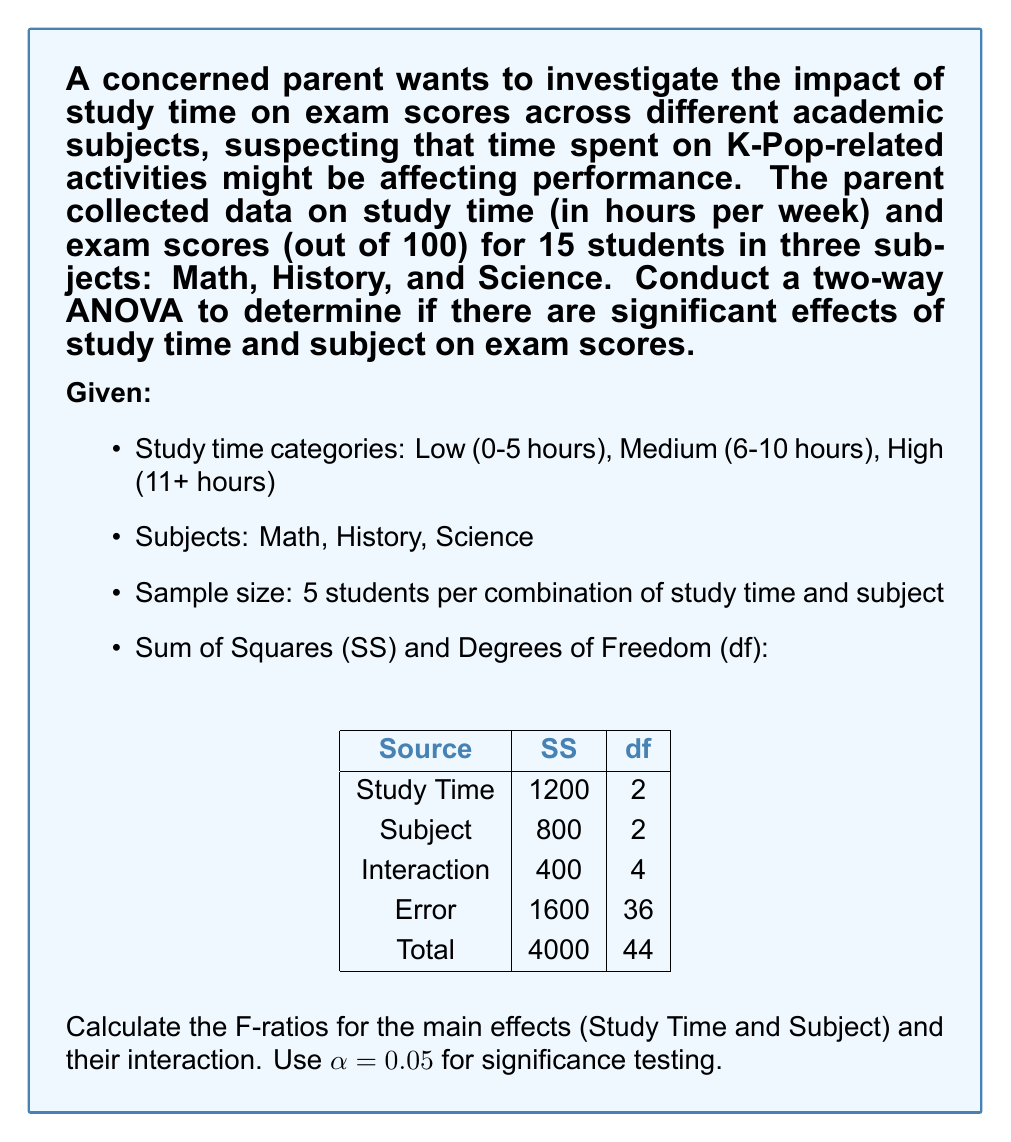Provide a solution to this math problem. To conduct a two-way ANOVA, we need to calculate the Mean Square (MS) for each source of variation and then compute the F-ratios. Here's a step-by-step explanation:

1. Calculate Mean Squares (MS):
   MS = SS / df
   
   For Study Time: $MS_{StudyTime} = 1200 / 2 = 600$
   For Subject: $MS_{Subject} = 800 / 2 = 400$
   For Interaction: $MS_{Interaction} = 400 / 4 = 100$
   For Error: $MS_{Error} = 1600 / 36 \approx 44.44$

2. Calculate F-ratios:
   F-ratio = MS(effect) / MS(error)
   
   For Study Time: $F_{StudyTime} = 600 / 44.44 \approx 13.50$
   For Subject: $F_{Subject} = 400 / 44.44 \approx 9.00$
   For Interaction: $F_{Interaction} = 100 / 44.44 \approx 2.25$

3. Determine critical F-values:
   For $\alpha = 0.05$:
   $F_{crit}(2, 36) \approx 3.26$ (for Study Time and Subject)
   $F_{crit}(4, 36) \approx 2.63$ (for Interaction)

4. Compare F-ratios to critical F-values:
   Study Time: 13.50 > 3.26, significant effect
   Subject: 9.00 > 3.26, significant effect
   Interaction: 2.25 < 2.63, no significant interaction
Answer: F-ratios:
Study Time: $F_{StudyTime} \approx 13.50$
Subject: $F_{Subject} \approx 9.00$
Interaction: $F_{Interaction} \approx 2.25$

Conclusions:
Study Time: Significant effect (p < 0.05)
Subject: Significant effect (p < 0.05)
Interaction: No significant effect (p > 0.05) 